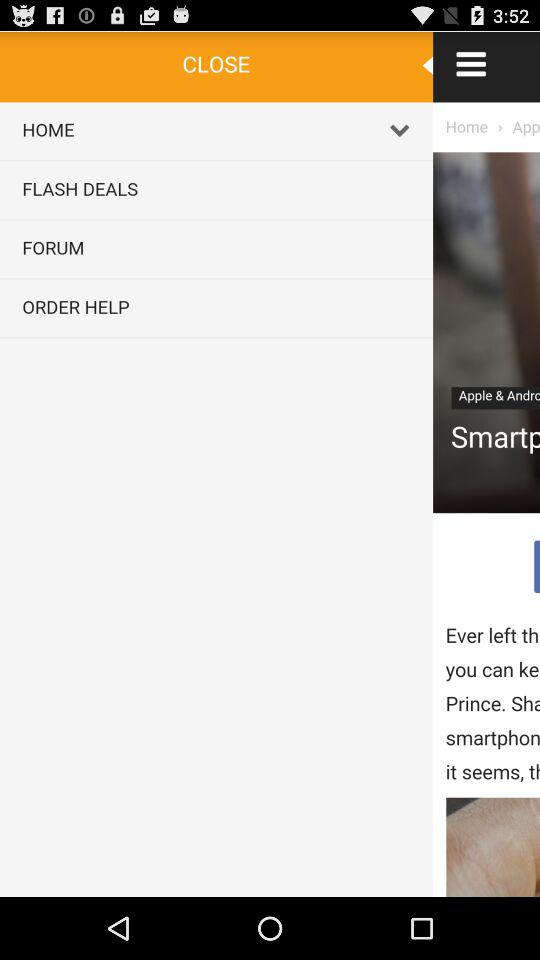What is the price of "Original Xiaomi Mi Wifi 3 Router EU Plug Smar..."? The price is US$33.99. 